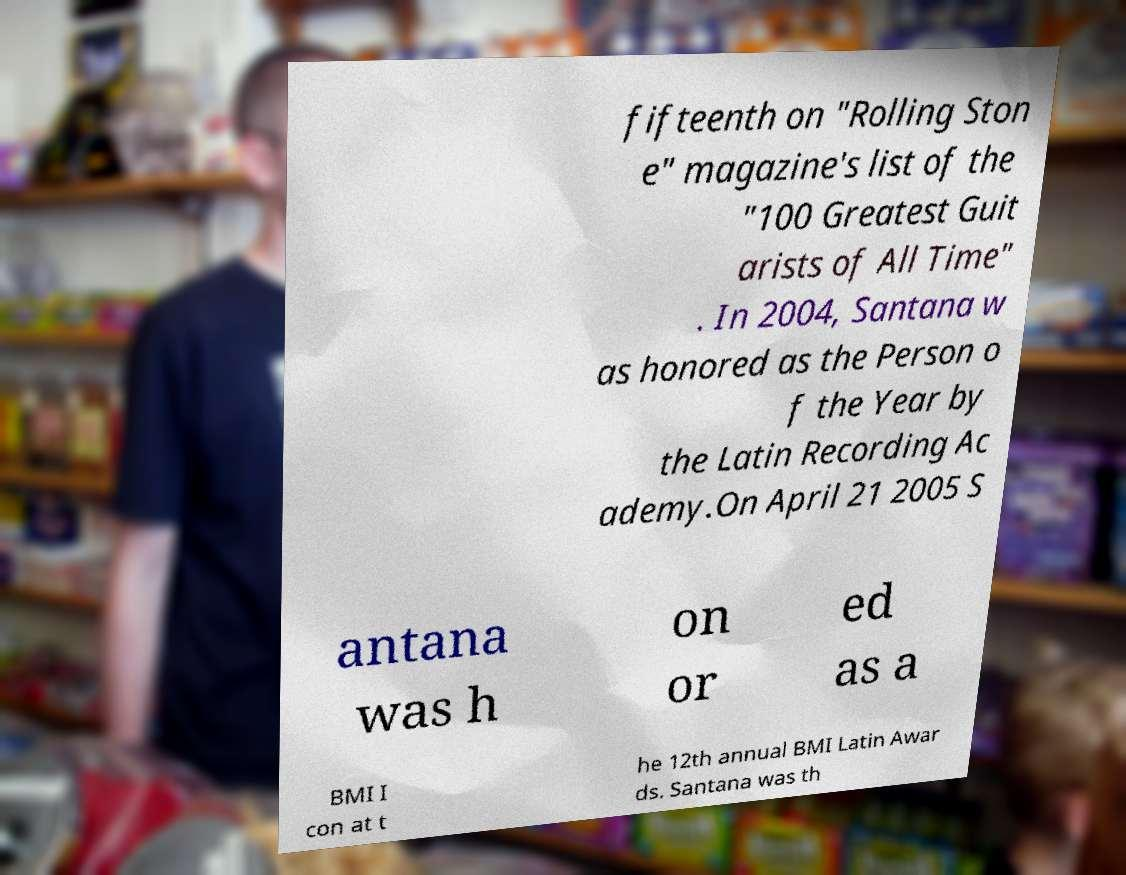There's text embedded in this image that I need extracted. Can you transcribe it verbatim? fifteenth on "Rolling Ston e" magazine's list of the "100 Greatest Guit arists of All Time" . In 2004, Santana w as honored as the Person o f the Year by the Latin Recording Ac ademy.On April 21 2005 S antana was h on or ed as a BMI I con at t he 12th annual BMI Latin Awar ds. Santana was th 